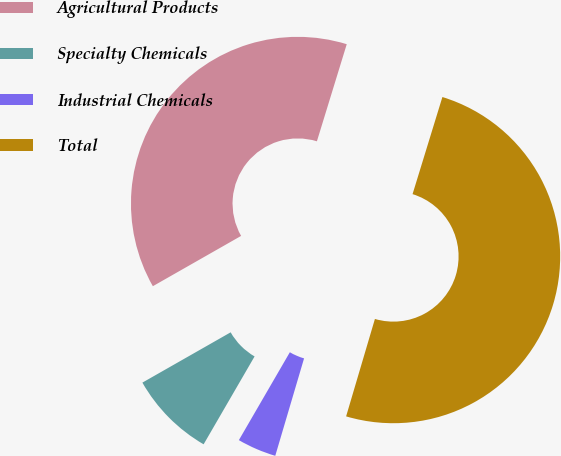Convert chart. <chart><loc_0><loc_0><loc_500><loc_500><pie_chart><fcel>Agricultural Products<fcel>Specialty Chemicals<fcel>Industrial Chemicals<fcel>Total<nl><fcel>37.99%<fcel>8.39%<fcel>3.79%<fcel>49.83%<nl></chart> 